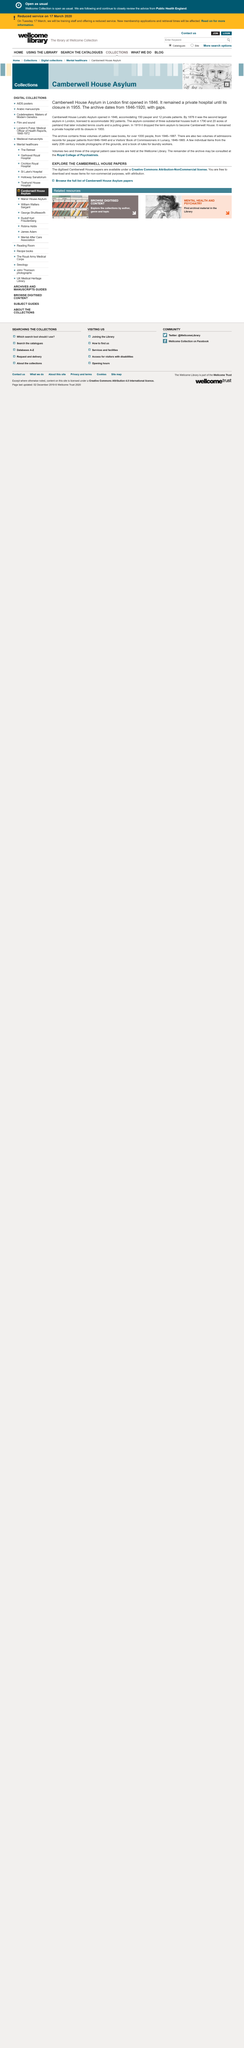Highlight a few significant elements in this photo. The Camberwell House Asylum was closed in 1955. The archive contains three volumes that contain records of over 1000 patients. The Camberwell House Asylum opened in 1846. 